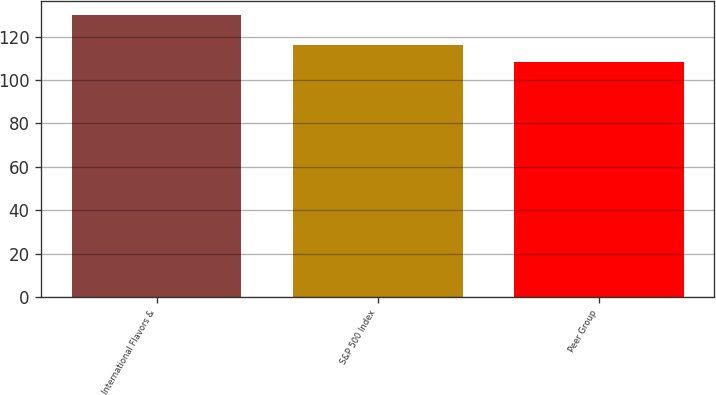Convert chart to OTSL. <chart><loc_0><loc_0><loc_500><loc_500><bar_chart><fcel>International Flavors &<fcel>S&P 500 Index<fcel>Peer Group<nl><fcel>129.72<fcel>116<fcel>108.21<nl></chart> 